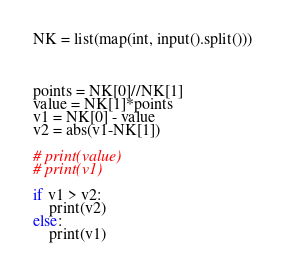Convert code to text. <code><loc_0><loc_0><loc_500><loc_500><_Python_>NK = list(map(int, input().split()))



points = NK[0]//NK[1]
value = NK[1]*points
v1 = NK[0] - value
v2 = abs(v1-NK[1])

# print(value)
# print(v1)

if v1 > v2:
    print(v2)
else:
    print(v1)</code> 